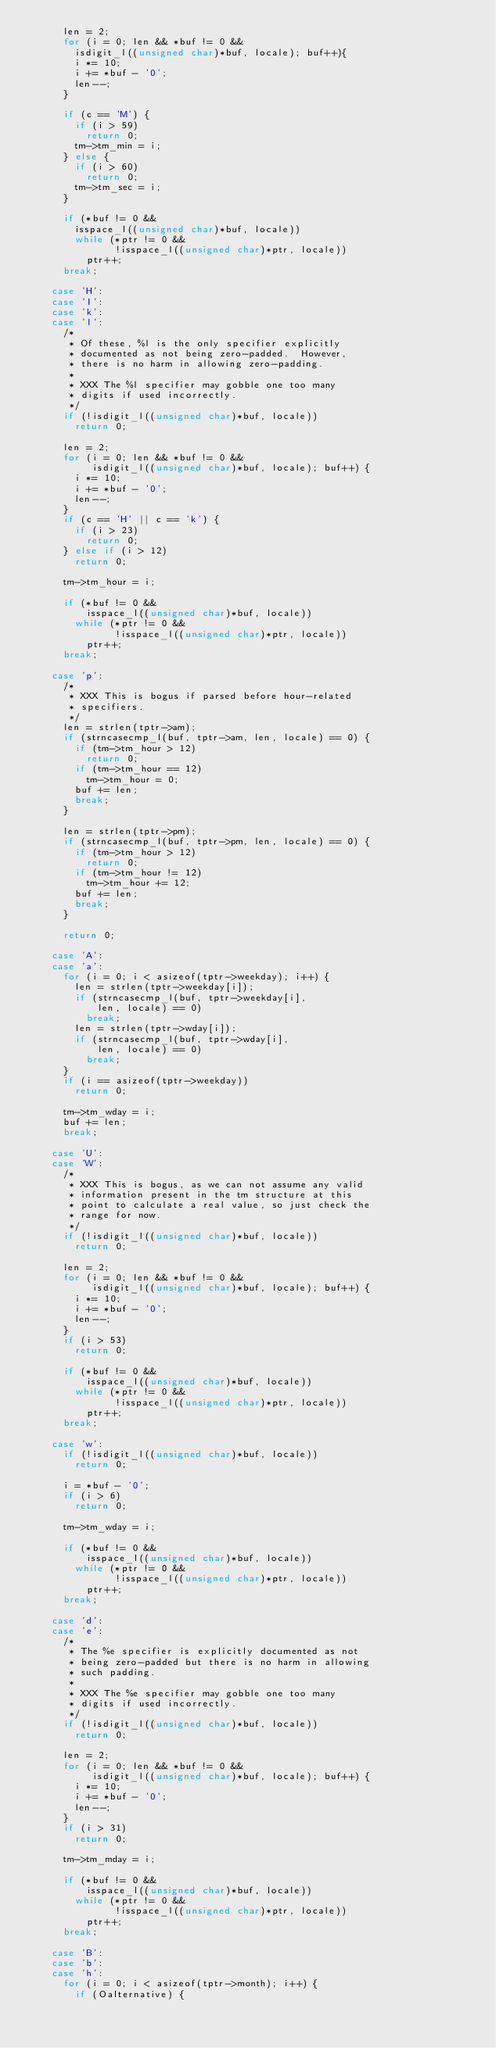<code> <loc_0><loc_0><loc_500><loc_500><_C_>			len = 2;
			for (i = 0; len && *buf != 0 &&
				isdigit_l((unsigned char)*buf, locale); buf++){
				i *= 10;
				i += *buf - '0';
				len--;
			}

			if (c == 'M') {
				if (i > 59)
					return 0;
				tm->tm_min = i;
			} else {
				if (i > 60)
					return 0;
				tm->tm_sec = i;
			}

			if (*buf != 0 &&
				isspace_l((unsigned char)*buf, locale))
				while (*ptr != 0 &&
				       !isspace_l((unsigned char)*ptr, locale))
					ptr++;
			break;

		case 'H':
		case 'I':
		case 'k':
		case 'l':
			/*
			 * Of these, %l is the only specifier explicitly
			 * documented as not being zero-padded.  However,
			 * there is no harm in allowing zero-padding.
			 *
			 * XXX The %l specifier may gobble one too many
			 * digits if used incorrectly.
			 */
			if (!isdigit_l((unsigned char)*buf, locale))
				return 0;

			len = 2;
			for (i = 0; len && *buf != 0 &&
			     isdigit_l((unsigned char)*buf, locale); buf++) {
				i *= 10;
				i += *buf - '0';
				len--;
			}
			if (c == 'H' || c == 'k') {
				if (i > 23)
					return 0;
			} else if (i > 12)
				return 0;

			tm->tm_hour = i;

			if (*buf != 0 &&
			    isspace_l((unsigned char)*buf, locale))
				while (*ptr != 0 &&
				       !isspace_l((unsigned char)*ptr, locale))
					ptr++;
			break;

		case 'p':
			/*
			 * XXX This is bogus if parsed before hour-related
			 * specifiers.
			 */
			len = strlen(tptr->am);
			if (strncasecmp_l(buf, tptr->am, len, locale) == 0) {
				if (tm->tm_hour > 12)
					return 0;
				if (tm->tm_hour == 12)
					tm->tm_hour = 0;
				buf += len;
				break;
			}

			len = strlen(tptr->pm);
			if (strncasecmp_l(buf, tptr->pm, len, locale) == 0) {
				if (tm->tm_hour > 12)
					return 0;
				if (tm->tm_hour != 12)
					tm->tm_hour += 12;
				buf += len;
				break;
			}

			return 0;

		case 'A':
		case 'a':
			for (i = 0; i < asizeof(tptr->weekday); i++) {
				len = strlen(tptr->weekday[i]);
				if (strncasecmp_l(buf, tptr->weekday[i],
						len, locale) == 0)
					break;
				len = strlen(tptr->wday[i]);
				if (strncasecmp_l(buf, tptr->wday[i],
						len, locale) == 0)
					break;
			}
			if (i == asizeof(tptr->weekday))
				return 0;

			tm->tm_wday = i;
			buf += len;
			break;

		case 'U':
		case 'W':
			/*
			 * XXX This is bogus, as we can not assume any valid
			 * information present in the tm structure at this
			 * point to calculate a real value, so just check the
			 * range for now.
			 */
			if (!isdigit_l((unsigned char)*buf, locale))
				return 0;

			len = 2;
			for (i = 0; len && *buf != 0 &&
			     isdigit_l((unsigned char)*buf, locale); buf++) {
				i *= 10;
				i += *buf - '0';
				len--;
			}
			if (i > 53)
				return 0;

			if (*buf != 0 &&
			    isspace_l((unsigned char)*buf, locale))
				while (*ptr != 0 &&
				       !isspace_l((unsigned char)*ptr, locale))
					ptr++;
			break;

		case 'w':
			if (!isdigit_l((unsigned char)*buf, locale))
				return 0;

			i = *buf - '0';
			if (i > 6)
				return 0;

			tm->tm_wday = i;

			if (*buf != 0 &&
			    isspace_l((unsigned char)*buf, locale))
				while (*ptr != 0 &&
				       !isspace_l((unsigned char)*ptr, locale))
					ptr++;
			break;

		case 'd':
		case 'e':
			/*
			 * The %e specifier is explicitly documented as not
			 * being zero-padded but there is no harm in allowing
			 * such padding.
			 *
			 * XXX The %e specifier may gobble one too many
			 * digits if used incorrectly.
			 */
			if (!isdigit_l((unsigned char)*buf, locale))
				return 0;

			len = 2;
			for (i = 0; len && *buf != 0 &&
			     isdigit_l((unsigned char)*buf, locale); buf++) {
				i *= 10;
				i += *buf - '0';
				len--;
			}
			if (i > 31)
				return 0;

			tm->tm_mday = i;

			if (*buf != 0 &&
			    isspace_l((unsigned char)*buf, locale))
				while (*ptr != 0 &&
				       !isspace_l((unsigned char)*ptr, locale))
					ptr++;
			break;

		case 'B':
		case 'b':
		case 'h':
			for (i = 0; i < asizeof(tptr->month); i++) {
				if (Oalternative) {</code> 